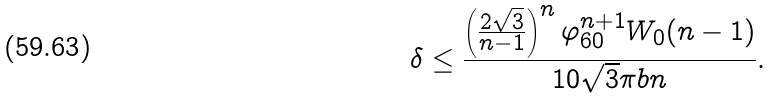Convert formula to latex. <formula><loc_0><loc_0><loc_500><loc_500>\delta \leq \frac { \left ( \frac { 2 \sqrt { 3 } } { n - 1 } \right ) ^ { n } \varphi _ { 6 0 } ^ { n + 1 } W _ { 0 } ( n - 1 ) } { 1 0 \sqrt { 3 } \pi b n } .</formula> 